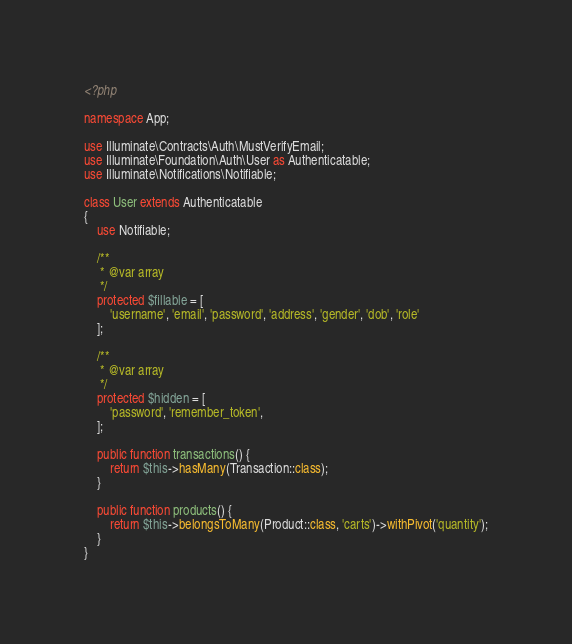<code> <loc_0><loc_0><loc_500><loc_500><_PHP_><?php

namespace App;

use Illuminate\Contracts\Auth\MustVerifyEmail;
use Illuminate\Foundation\Auth\User as Authenticatable;
use Illuminate\Notifications\Notifiable;

class User extends Authenticatable
{
    use Notifiable;

    /**
     * @var array
     */
    protected $fillable = [
        'username', 'email', 'password', 'address', 'gender', 'dob', 'role'
    ];

    /**
     * @var array
     */
    protected $hidden = [
        'password', 'remember_token',
    ];

    public function transactions() {
        return $this->hasMany(Transaction::class);
    }

    public function products() {
        return $this->belongsToMany(Product::class, 'carts')->withPivot('quantity');
    }
}
</code> 